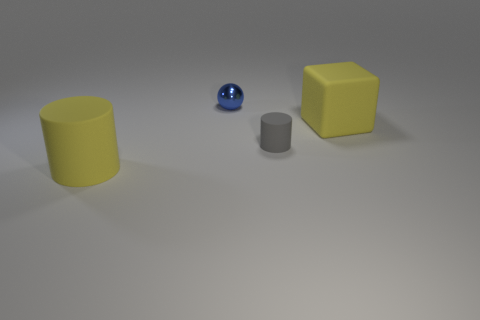How many gray matte cylinders have the same size as the sphere?
Provide a short and direct response. 1. What size is the rubber cylinder to the right of the yellow object that is in front of the tiny gray thing?
Provide a succinct answer. Small. There is a tiny thing that is left of the small gray matte cylinder; is its shape the same as the large yellow matte object that is behind the tiny gray rubber cylinder?
Offer a terse response. No. What color is the thing that is on the left side of the gray object and in front of the large matte cube?
Make the answer very short. Yellow. Is there a big block that has the same color as the big matte cylinder?
Provide a short and direct response. Yes. What is the color of the small rubber cylinder to the left of the large cube?
Make the answer very short. Gray. There is a blue metal sphere on the left side of the block; is there a yellow block that is behind it?
Keep it short and to the point. No. Do the matte block and the rubber cylinder left of the gray rubber thing have the same color?
Offer a very short reply. Yes. Is there a yellow block made of the same material as the yellow cylinder?
Your answer should be very brief. Yes. What number of metallic things are there?
Your response must be concise. 1. 